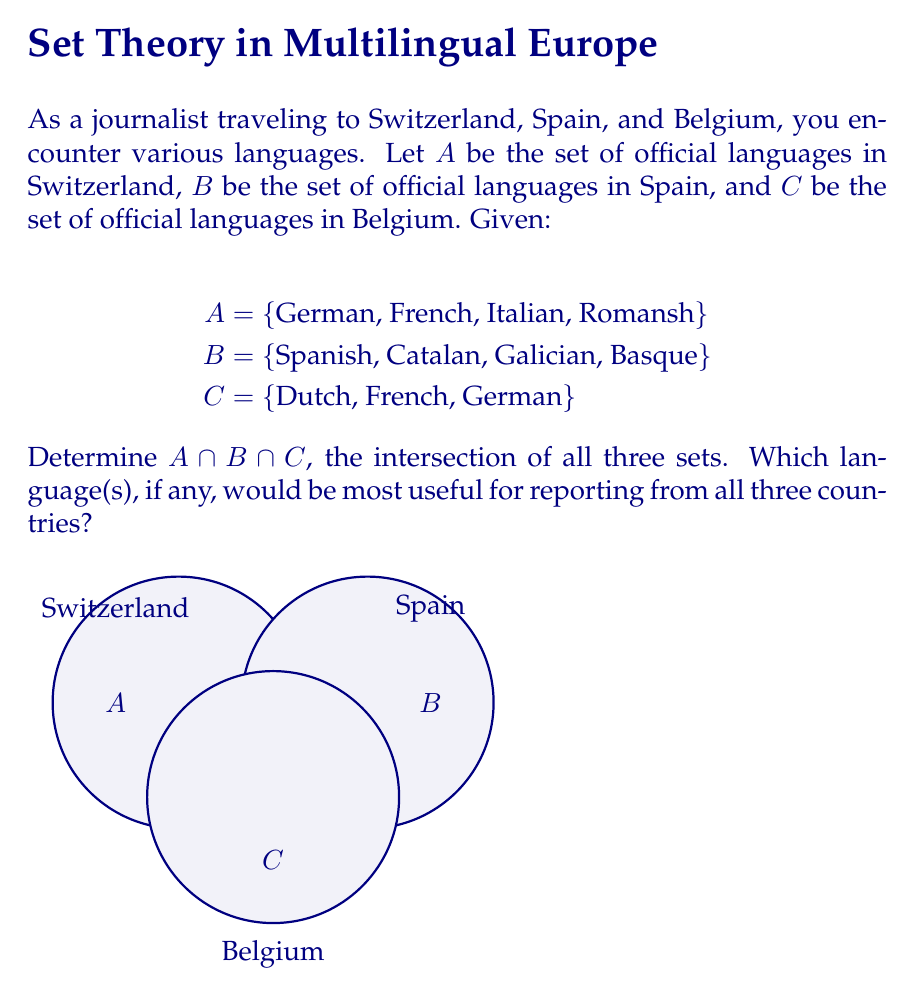Teach me how to tackle this problem. To find the intersection of sets A, B, and C, we need to identify the elements that are present in all three sets. Let's approach this step-by-step:

1) First, let's list out the sets:
   A = {German, French, Italian, Romansh}
   B = {Spanish, Catalan, Galician, Basque}
   C = {Dutch, French, German}

2) Now, let's find the elements that are common to all three sets:

   - German is in A and C, but not in B
   - French is in A and C, but not in B
   - Italian is only in A
   - Romansh is only in A
   - Spanish, Catalan, Galician, and Basque are only in B
   - Dutch is only in C

3) We can express this mathematically as:

   $A \cap B \cap C = \{x | x \in A \text{ and } x \in B \text{ and } x \in C\}$

4) From our analysis, we can see that there is no language that appears in all three sets.

Therefore, the intersection of A, B, and C is the empty set, denoted as $\emptyset$ or {}.

This means that there is no single language that would be universally official across all three countries for reporting purposes.
Answer: $A \cap B \cap C = \emptyset$ 